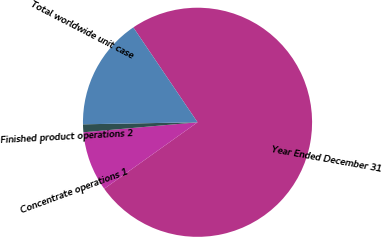<chart> <loc_0><loc_0><loc_500><loc_500><pie_chart><fcel>Year Ended December 31<fcel>Concentrate operations 1<fcel>Finished product operations 2<fcel>Total worldwide unit case<nl><fcel>74.61%<fcel>8.46%<fcel>1.11%<fcel>15.81%<nl></chart> 